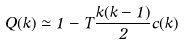Convert formula to latex. <formula><loc_0><loc_0><loc_500><loc_500>Q ( k ) \simeq 1 - T \frac { k ( k - 1 ) } { 2 } c ( k )</formula> 